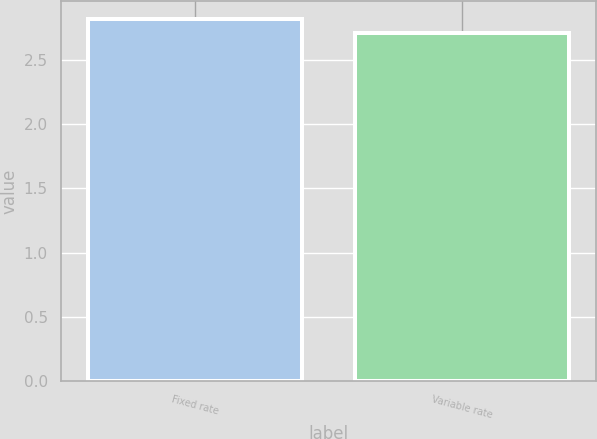<chart> <loc_0><loc_0><loc_500><loc_500><bar_chart><fcel>Fixed rate<fcel>Variable rate<nl><fcel>2.82<fcel>2.71<nl></chart> 